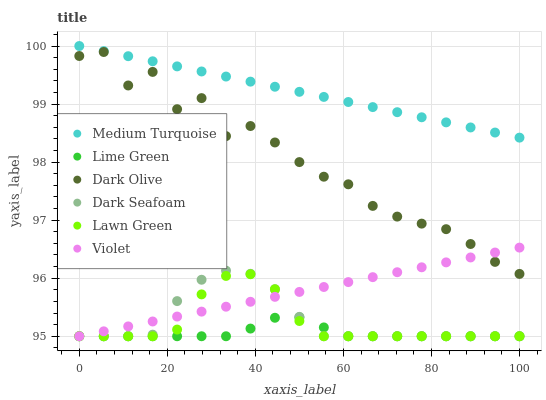Does Lime Green have the minimum area under the curve?
Answer yes or no. Yes. Does Medium Turquoise have the maximum area under the curve?
Answer yes or no. Yes. Does Dark Olive have the minimum area under the curve?
Answer yes or no. No. Does Dark Olive have the maximum area under the curve?
Answer yes or no. No. Is Medium Turquoise the smoothest?
Answer yes or no. Yes. Is Dark Olive the roughest?
Answer yes or no. Yes. Is Dark Seafoam the smoothest?
Answer yes or no. No. Is Dark Seafoam the roughest?
Answer yes or no. No. Does Lawn Green have the lowest value?
Answer yes or no. Yes. Does Dark Olive have the lowest value?
Answer yes or no. No. Does Medium Turquoise have the highest value?
Answer yes or no. Yes. Does Dark Olive have the highest value?
Answer yes or no. No. Is Dark Seafoam less than Medium Turquoise?
Answer yes or no. Yes. Is Medium Turquoise greater than Dark Seafoam?
Answer yes or no. Yes. Does Dark Olive intersect Violet?
Answer yes or no. Yes. Is Dark Olive less than Violet?
Answer yes or no. No. Is Dark Olive greater than Violet?
Answer yes or no. No. Does Dark Seafoam intersect Medium Turquoise?
Answer yes or no. No. 